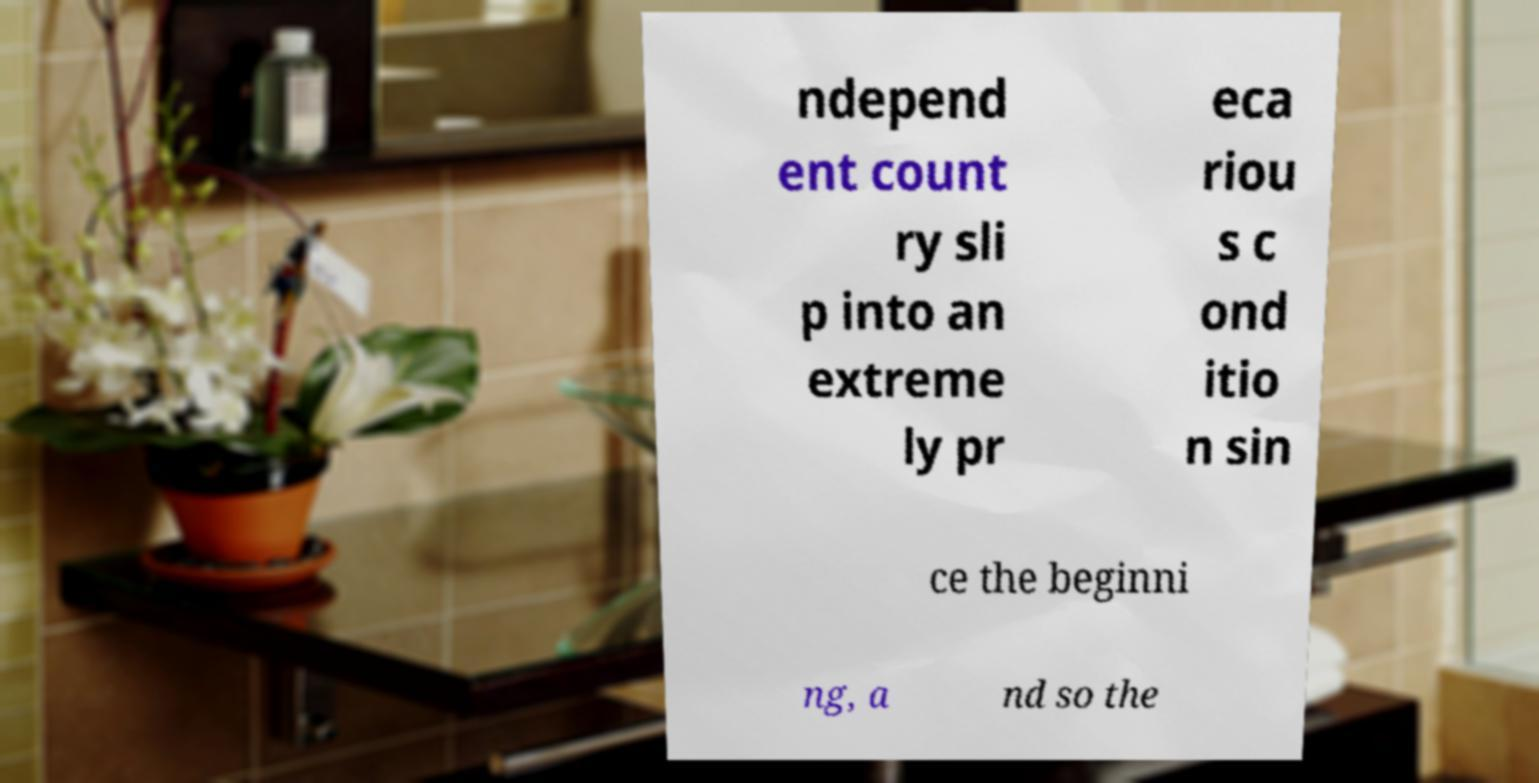I need the written content from this picture converted into text. Can you do that? ndepend ent count ry sli p into an extreme ly pr eca riou s c ond itio n sin ce the beginni ng, a nd so the 